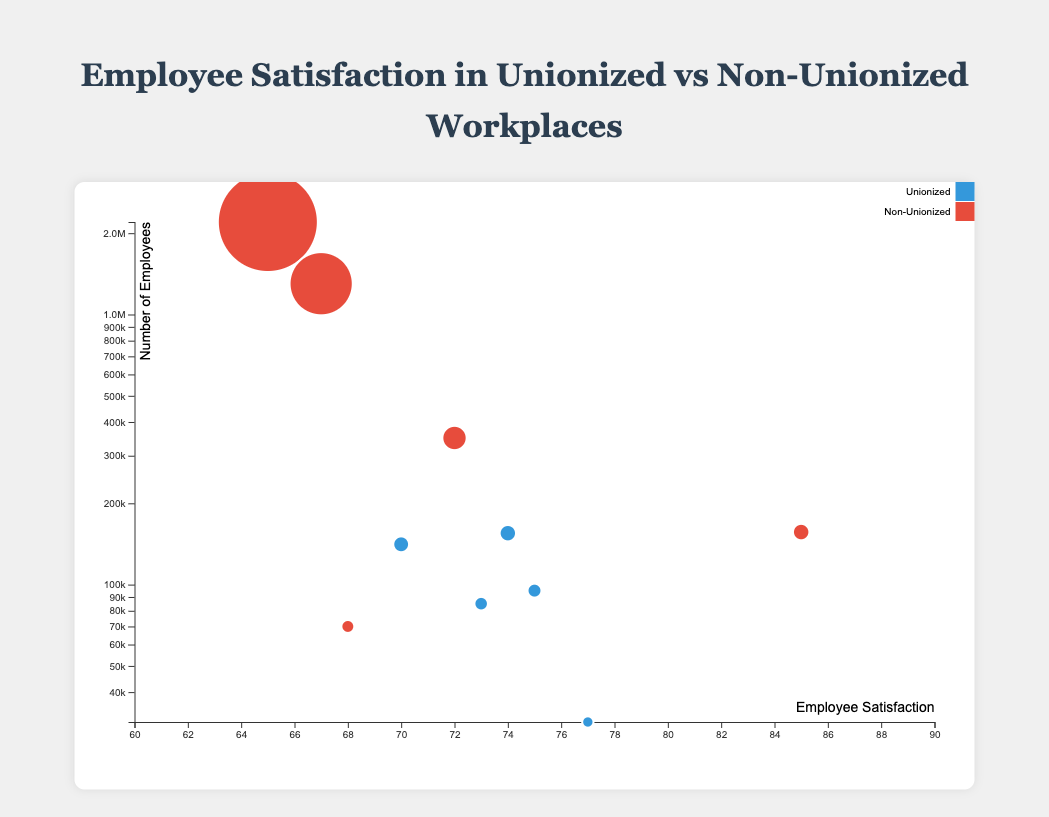What is the employee satisfaction level at Google? By looking at the bubble corresponding to Google in the chart, it is labeled with an employee satisfaction level.
Answer: 85 How does employee satisfaction at Ford compare to that at Boeing? Ford has an employee satisfaction level of 75, while Boeing has a satisfaction level of 70, as shown by the vertical position of their respective bubbles. Therefore, Ford has a higher satisfaction level than Boeing.
Answer: Ford has higher satisfaction Which company has the largest bubble in the chart? The size of the bubble represents the number of employees. By identifying the largest bubble, it is clear that Walmart has the largest bubble, indicating it has the most employees.
Answer: Walmart What is the difference in employee satisfaction between the unionized and non-unionized companies? The employee satisfaction levels can be averaged separately for unionized and non-unionized companies. Unionized companies have satisfaction levels of 75, 77, 73, 70, and 74, averaging to 73.8. Non-unionized companies have satisfaction levels of 68, 65, 85, 67, and 72, averaging to 71.4. The difference is 73.8 - 71.4.
Answer: 2.4 Which non-unionized company has the highest employee satisfaction level? By examining the non-unionized companies' bubbles, Google has the highest employee satisfaction of 85.
Answer: Google What is the median employee satisfaction level among all companies? To find the median satisfaction level, list all satisfaction levels: 65, 67, 68, 70, 72, 73, 74, 75, 77, 85. The median is the middle value, which is the average of the 5th and 6th values: (72 + 73) / 2.
Answer: 72.5 How many companies have an employee satisfaction level higher than 70? By visually counting the bubbles with satisfaction levels greater than 70, there are six companies: Ford, Kellogg, Google, United Airlines, Starbucks, and General Motors.
Answer: 6 Is there a trend in employee satisfaction based on whether companies are unionized or not? Unionized companies generally have higher satisfaction levels. For example, Ford, Kellogg, United Airlines, Boeing, and General Motors show a higher average satisfaction level compared to non-unionized ones like Tesla, Walmart, Amazon, and Starbucks.
Answer: Yes, unionized companies have higher satisfaction How does the number of employees correlate with employee satisfaction? Observing the bubble chart, there doesn't seem to be a clear correlation. Companies like Google and Walmart show that high satisfaction and low satisfaction can both occur in companies with a large number of employees. A detailed statistical analysis is needed for precise correlation.
Answer: No clear correlation Which unionized company has the lowest employee satisfaction level? Among unionized companies, Boeing has the lowest employee satisfaction level with a value of 70, as indicated by the position of its bubble.
Answer: Boeing 